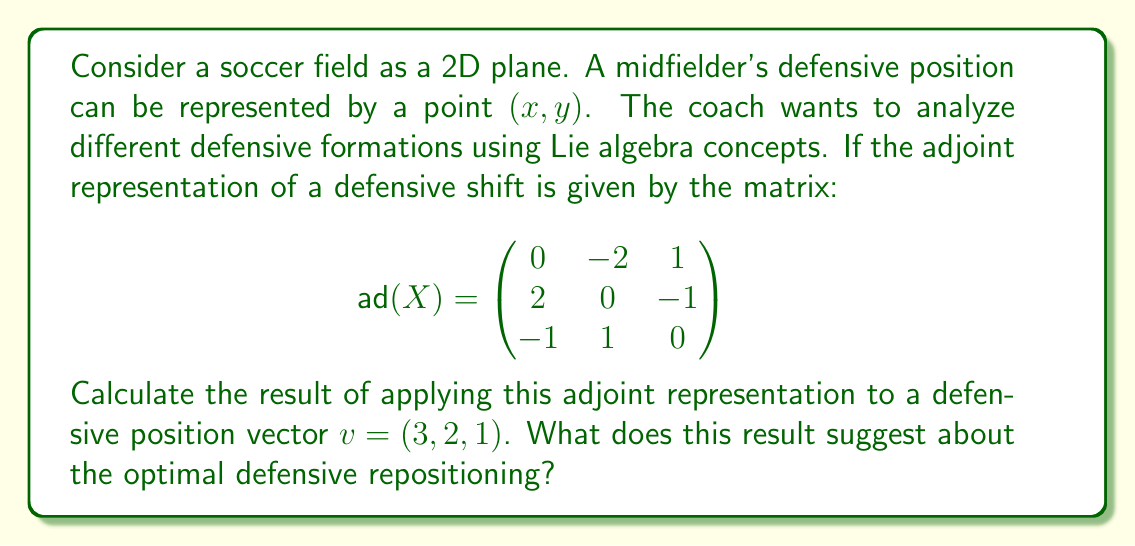Can you answer this question? To solve this problem, we need to understand that the adjoint representation in Lie algebra can be used to analyze transformations in defensive positioning. Here's how we can approach this:

1) The adjoint representation $\text{ad}(X)$ is given as a 3x3 matrix. This suggests that our defensive positioning is being considered in a 3D space, possibly accounting for forward/backward, left/right, and some additional tactical dimension.

2) We need to multiply the matrix $\text{ad}(X)$ by the vector $v = (3, 2, 1)$. This operation is performed as follows:

   $$
   \text{ad}(X)v = \begin{pmatrix}
   0 & -2 & 1 \\
   2 & 0 & -1 \\
   -1 & 1 & 0
   \end{pmatrix} \begin{pmatrix} 3 \\ 2 \\ 1 \end{pmatrix}
   $$

3) Let's perform the matrix multiplication:

   $$
   \begin{aligned}
   \text{ad}(X)v &= \begin{pmatrix}
   (0 \cdot 3) + (-2 \cdot 2) + (1 \cdot 1) \\
   (2 \cdot 3) + (0 \cdot 2) + (-1 \cdot 1) \\
   (-1 \cdot 3) + (1 \cdot 2) + (0 \cdot 1)
   \end{pmatrix} \\[10pt]
   &= \begin{pmatrix}
   0 - 4 + 1 \\
   6 + 0 - 1 \\
   -3 + 2 + 0
   \end{pmatrix} \\[10pt]
   &= \begin{pmatrix}
   -3 \\
   5 \\
   -1
   \end{pmatrix}
   \end{aligned}
   $$

4) The resulting vector $(-3, 5, -1)$ represents the optimal defensive repositioning based on the given adjoint representation.

5) Interpreting this result in the context of soccer:
   - The negative x-component (-3) suggests moving left on the field.
   - The positive y-component (5) indicates moving forward.
   - The small negative z-component (-1) might represent a slight adjustment in the tactical dimension, perhaps dropping back slightly in formation.
Answer: The result of applying the adjoint representation to the defensive position vector is $(-3, 5, -1)$. This suggests that the optimal defensive repositioning involves moving left, pushing forward, and making a slight tactical adjustment, possibly dropping back in formation. 